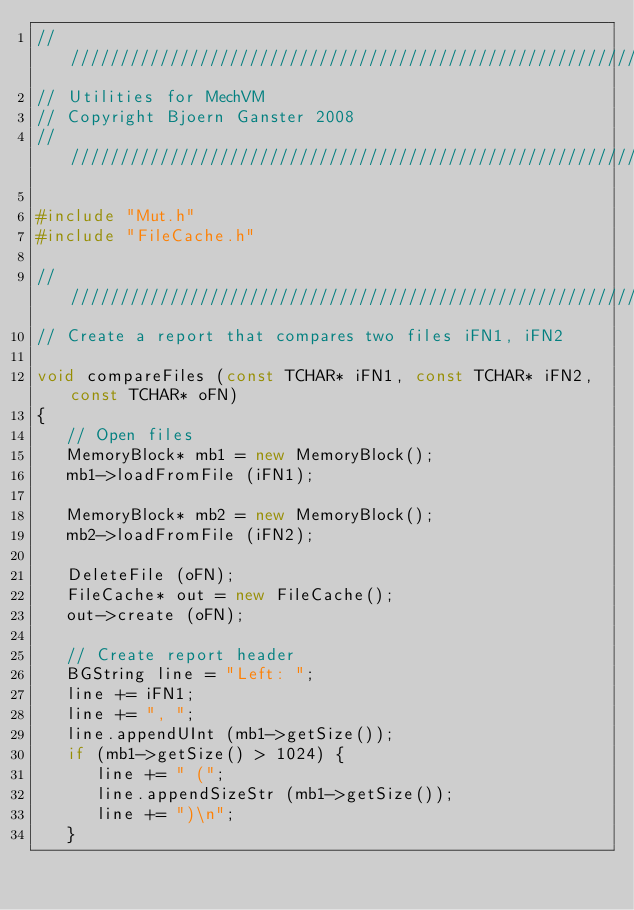Convert code to text. <code><loc_0><loc_0><loc_500><loc_500><_C++_>////////////////////////////////////////////////////////////////////////////////
// Utilities for MechVM
// Copyright Bjoern Ganster 2008
////////////////////////////////////////////////////////////////////////////////

#include "Mut.h"
#include "FileCache.h"

////////////////////////////////////////////////////////////////////////////////
// Create a report that compares two files iFN1, iFN2

void compareFiles (const TCHAR* iFN1, const TCHAR* iFN2, const TCHAR* oFN)
{
   // Open files
   MemoryBlock* mb1 = new MemoryBlock();
   mb1->loadFromFile (iFN1);

   MemoryBlock* mb2 = new MemoryBlock();
   mb2->loadFromFile (iFN2);

   DeleteFile (oFN);
   FileCache* out = new FileCache();
   out->create (oFN);

   // Create report header
   BGString line = "Left: ";
   line += iFN1;
   line += ", ";
   line.appendUInt (mb1->getSize());
   if (mb1->getSize() > 1024) {
      line += " (";
      line.appendSizeStr (mb1->getSize());
      line += ")\n";
   }</code> 